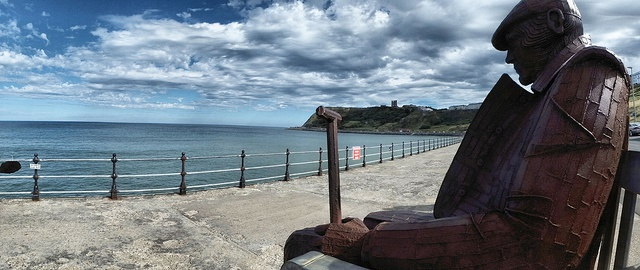Describe the objects in this image and their specific colors. I can see people in lightblue, black, gray, and darkgray tones, bench in lightblue, black, darkgray, gray, and lightgray tones, bench in lightblue, gray, darkgray, and black tones, and car in lightblue, gray, black, and darkgray tones in this image. 